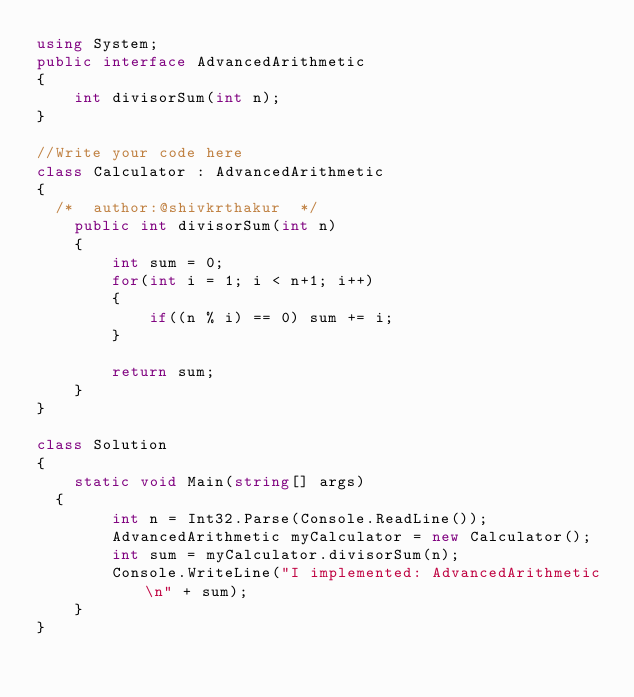<code> <loc_0><loc_0><loc_500><loc_500><_C#_>using System;
public interface AdvancedArithmetic
{
    int divisorSum(int n);
}

//Write your code here
class Calculator : AdvancedArithmetic 
{
	/*	author:@shivkrthakur  */
    public int divisorSum(int n)
    {
        int sum = 0;
        for(int i = 1; i < n+1; i++)
        {
            if((n % i) == 0) sum += i;   
        }
        
        return sum;
    }
}

class Solution
{
    static void Main(string[] args)
	{
        int n = Int32.Parse(Console.ReadLine());
      	AdvancedArithmetic myCalculator = new Calculator();
        int sum = myCalculator.divisorSum(n);
        Console.WriteLine("I implemented: AdvancedArithmetic\n" + sum); 
    }
}</code> 